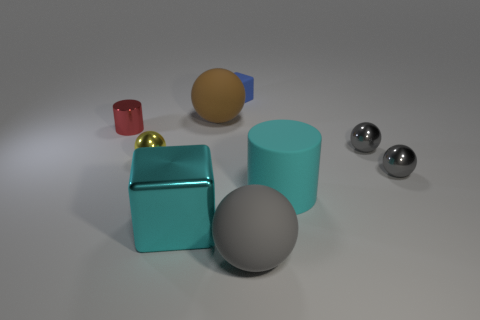Does the tiny object that is behind the red thing have the same material as the tiny red cylinder?
Provide a short and direct response. No. What is the color of the ball that is the same size as the brown matte thing?
Ensure brevity in your answer.  Gray. Are there any purple rubber things of the same shape as the blue rubber object?
Offer a terse response. No. There is a cube that is on the left side of the large matte ball that is on the left side of the big sphere that is in front of the yellow shiny sphere; what color is it?
Provide a short and direct response. Cyan. What number of metal objects are red cylinders or large cyan objects?
Keep it short and to the point. 2. Is the number of cyan cubes in front of the small shiny cylinder greater than the number of small rubber objects in front of the cyan metal thing?
Give a very brief answer. Yes. How many other objects are there of the same size as the brown ball?
Your response must be concise. 3. How big is the cube that is on the left side of the large rubber sphere behind the big cyan rubber thing?
Provide a short and direct response. Large. What number of tiny objects are either cylinders or blue things?
Provide a short and direct response. 2. There is a block right of the cyan object to the left of the small thing behind the red metal thing; what is its size?
Your response must be concise. Small. 